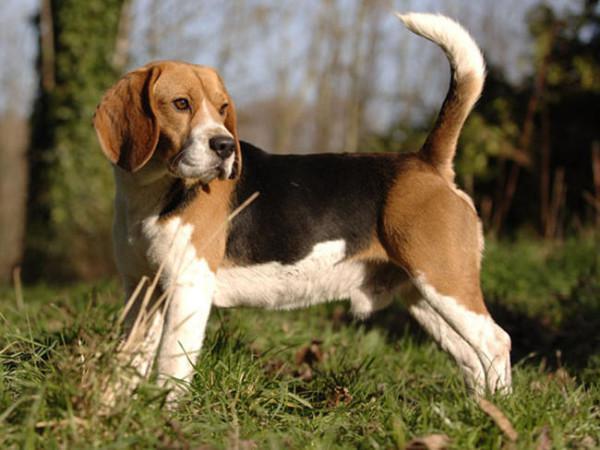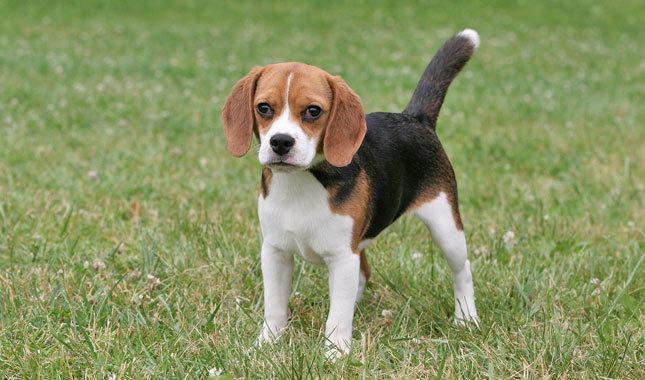The first image is the image on the left, the second image is the image on the right. Evaluate the accuracy of this statement regarding the images: "The dog in the right image is on a leash.". Is it true? Answer yes or no. No. 